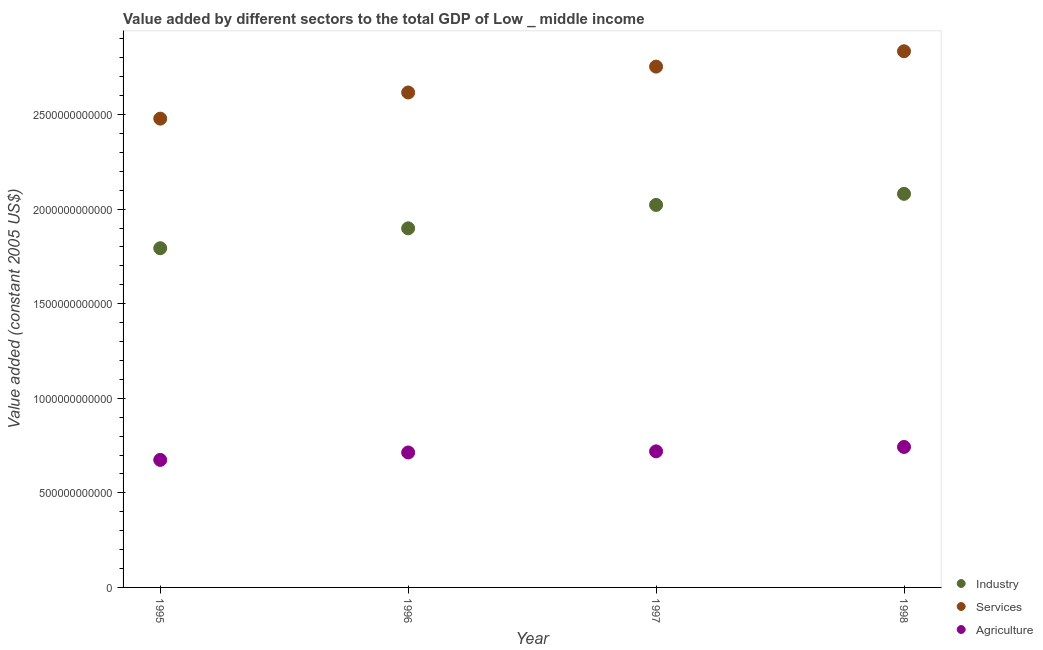What is the value added by industrial sector in 1997?
Ensure brevity in your answer.  2.02e+12. Across all years, what is the maximum value added by industrial sector?
Make the answer very short. 2.08e+12. Across all years, what is the minimum value added by agricultural sector?
Ensure brevity in your answer.  6.74e+11. In which year was the value added by services minimum?
Provide a succinct answer. 1995. What is the total value added by services in the graph?
Provide a succinct answer. 1.07e+13. What is the difference between the value added by services in 1996 and that in 1997?
Offer a very short reply. -1.37e+11. What is the difference between the value added by services in 1998 and the value added by industrial sector in 1995?
Your response must be concise. 1.04e+12. What is the average value added by agricultural sector per year?
Offer a very short reply. 7.12e+11. In the year 1995, what is the difference between the value added by agricultural sector and value added by services?
Your answer should be compact. -1.80e+12. What is the ratio of the value added by industrial sector in 1995 to that in 1997?
Make the answer very short. 0.89. Is the value added by services in 1995 less than that in 1996?
Make the answer very short. Yes. Is the difference between the value added by agricultural sector in 1995 and 1998 greater than the difference between the value added by services in 1995 and 1998?
Your answer should be very brief. Yes. What is the difference between the highest and the second highest value added by industrial sector?
Offer a very short reply. 5.85e+1. What is the difference between the highest and the lowest value added by industrial sector?
Give a very brief answer. 2.88e+11. In how many years, is the value added by agricultural sector greater than the average value added by agricultural sector taken over all years?
Your answer should be compact. 3. Is the value added by industrial sector strictly greater than the value added by services over the years?
Ensure brevity in your answer.  No. How many dotlines are there?
Offer a very short reply. 3. How many years are there in the graph?
Give a very brief answer. 4. What is the difference between two consecutive major ticks on the Y-axis?
Keep it short and to the point. 5.00e+11. Are the values on the major ticks of Y-axis written in scientific E-notation?
Offer a very short reply. No. Does the graph contain grids?
Keep it short and to the point. No. How many legend labels are there?
Your answer should be very brief. 3. How are the legend labels stacked?
Offer a very short reply. Vertical. What is the title of the graph?
Your response must be concise. Value added by different sectors to the total GDP of Low _ middle income. What is the label or title of the Y-axis?
Your response must be concise. Value added (constant 2005 US$). What is the Value added (constant 2005 US$) in Industry in 1995?
Your response must be concise. 1.79e+12. What is the Value added (constant 2005 US$) in Services in 1995?
Ensure brevity in your answer.  2.48e+12. What is the Value added (constant 2005 US$) of Agriculture in 1995?
Ensure brevity in your answer.  6.74e+11. What is the Value added (constant 2005 US$) in Industry in 1996?
Your answer should be compact. 1.90e+12. What is the Value added (constant 2005 US$) of Services in 1996?
Make the answer very short. 2.62e+12. What is the Value added (constant 2005 US$) in Agriculture in 1996?
Provide a short and direct response. 7.13e+11. What is the Value added (constant 2005 US$) in Industry in 1997?
Your answer should be compact. 2.02e+12. What is the Value added (constant 2005 US$) in Services in 1997?
Your answer should be compact. 2.75e+12. What is the Value added (constant 2005 US$) in Agriculture in 1997?
Provide a short and direct response. 7.19e+11. What is the Value added (constant 2005 US$) in Industry in 1998?
Make the answer very short. 2.08e+12. What is the Value added (constant 2005 US$) in Services in 1998?
Ensure brevity in your answer.  2.83e+12. What is the Value added (constant 2005 US$) in Agriculture in 1998?
Your response must be concise. 7.43e+11. Across all years, what is the maximum Value added (constant 2005 US$) of Industry?
Offer a very short reply. 2.08e+12. Across all years, what is the maximum Value added (constant 2005 US$) of Services?
Offer a very short reply. 2.83e+12. Across all years, what is the maximum Value added (constant 2005 US$) of Agriculture?
Provide a short and direct response. 7.43e+11. Across all years, what is the minimum Value added (constant 2005 US$) in Industry?
Provide a succinct answer. 1.79e+12. Across all years, what is the minimum Value added (constant 2005 US$) of Services?
Provide a short and direct response. 2.48e+12. Across all years, what is the minimum Value added (constant 2005 US$) of Agriculture?
Offer a terse response. 6.74e+11. What is the total Value added (constant 2005 US$) of Industry in the graph?
Give a very brief answer. 7.80e+12. What is the total Value added (constant 2005 US$) in Services in the graph?
Offer a terse response. 1.07e+13. What is the total Value added (constant 2005 US$) of Agriculture in the graph?
Ensure brevity in your answer.  2.85e+12. What is the difference between the Value added (constant 2005 US$) in Industry in 1995 and that in 1996?
Offer a terse response. -1.05e+11. What is the difference between the Value added (constant 2005 US$) of Services in 1995 and that in 1996?
Give a very brief answer. -1.38e+11. What is the difference between the Value added (constant 2005 US$) of Agriculture in 1995 and that in 1996?
Offer a very short reply. -3.93e+1. What is the difference between the Value added (constant 2005 US$) in Industry in 1995 and that in 1997?
Provide a succinct answer. -2.29e+11. What is the difference between the Value added (constant 2005 US$) in Services in 1995 and that in 1997?
Your answer should be compact. -2.75e+11. What is the difference between the Value added (constant 2005 US$) of Agriculture in 1995 and that in 1997?
Keep it short and to the point. -4.52e+1. What is the difference between the Value added (constant 2005 US$) of Industry in 1995 and that in 1998?
Give a very brief answer. -2.88e+11. What is the difference between the Value added (constant 2005 US$) in Services in 1995 and that in 1998?
Keep it short and to the point. -3.56e+11. What is the difference between the Value added (constant 2005 US$) in Agriculture in 1995 and that in 1998?
Keep it short and to the point. -6.84e+1. What is the difference between the Value added (constant 2005 US$) of Industry in 1996 and that in 1997?
Offer a terse response. -1.24e+11. What is the difference between the Value added (constant 2005 US$) in Services in 1996 and that in 1997?
Your answer should be very brief. -1.37e+11. What is the difference between the Value added (constant 2005 US$) of Agriculture in 1996 and that in 1997?
Your answer should be very brief. -5.94e+09. What is the difference between the Value added (constant 2005 US$) of Industry in 1996 and that in 1998?
Provide a short and direct response. -1.82e+11. What is the difference between the Value added (constant 2005 US$) of Services in 1996 and that in 1998?
Your response must be concise. -2.18e+11. What is the difference between the Value added (constant 2005 US$) in Agriculture in 1996 and that in 1998?
Give a very brief answer. -2.91e+1. What is the difference between the Value added (constant 2005 US$) in Industry in 1997 and that in 1998?
Ensure brevity in your answer.  -5.85e+1. What is the difference between the Value added (constant 2005 US$) of Services in 1997 and that in 1998?
Provide a short and direct response. -8.12e+1. What is the difference between the Value added (constant 2005 US$) of Agriculture in 1997 and that in 1998?
Give a very brief answer. -2.32e+1. What is the difference between the Value added (constant 2005 US$) of Industry in 1995 and the Value added (constant 2005 US$) of Services in 1996?
Give a very brief answer. -8.23e+11. What is the difference between the Value added (constant 2005 US$) of Industry in 1995 and the Value added (constant 2005 US$) of Agriculture in 1996?
Offer a very short reply. 1.08e+12. What is the difference between the Value added (constant 2005 US$) of Services in 1995 and the Value added (constant 2005 US$) of Agriculture in 1996?
Offer a terse response. 1.77e+12. What is the difference between the Value added (constant 2005 US$) in Industry in 1995 and the Value added (constant 2005 US$) in Services in 1997?
Your answer should be very brief. -9.60e+11. What is the difference between the Value added (constant 2005 US$) of Industry in 1995 and the Value added (constant 2005 US$) of Agriculture in 1997?
Keep it short and to the point. 1.07e+12. What is the difference between the Value added (constant 2005 US$) in Services in 1995 and the Value added (constant 2005 US$) in Agriculture in 1997?
Your response must be concise. 1.76e+12. What is the difference between the Value added (constant 2005 US$) of Industry in 1995 and the Value added (constant 2005 US$) of Services in 1998?
Your response must be concise. -1.04e+12. What is the difference between the Value added (constant 2005 US$) of Industry in 1995 and the Value added (constant 2005 US$) of Agriculture in 1998?
Provide a short and direct response. 1.05e+12. What is the difference between the Value added (constant 2005 US$) in Services in 1995 and the Value added (constant 2005 US$) in Agriculture in 1998?
Make the answer very short. 1.74e+12. What is the difference between the Value added (constant 2005 US$) of Industry in 1996 and the Value added (constant 2005 US$) of Services in 1997?
Keep it short and to the point. -8.55e+11. What is the difference between the Value added (constant 2005 US$) in Industry in 1996 and the Value added (constant 2005 US$) in Agriculture in 1997?
Your answer should be compact. 1.18e+12. What is the difference between the Value added (constant 2005 US$) in Services in 1996 and the Value added (constant 2005 US$) in Agriculture in 1997?
Your response must be concise. 1.90e+12. What is the difference between the Value added (constant 2005 US$) of Industry in 1996 and the Value added (constant 2005 US$) of Services in 1998?
Give a very brief answer. -9.36e+11. What is the difference between the Value added (constant 2005 US$) of Industry in 1996 and the Value added (constant 2005 US$) of Agriculture in 1998?
Keep it short and to the point. 1.16e+12. What is the difference between the Value added (constant 2005 US$) in Services in 1996 and the Value added (constant 2005 US$) in Agriculture in 1998?
Provide a short and direct response. 1.87e+12. What is the difference between the Value added (constant 2005 US$) of Industry in 1997 and the Value added (constant 2005 US$) of Services in 1998?
Your answer should be compact. -8.12e+11. What is the difference between the Value added (constant 2005 US$) of Industry in 1997 and the Value added (constant 2005 US$) of Agriculture in 1998?
Offer a terse response. 1.28e+12. What is the difference between the Value added (constant 2005 US$) of Services in 1997 and the Value added (constant 2005 US$) of Agriculture in 1998?
Offer a very short reply. 2.01e+12. What is the average Value added (constant 2005 US$) in Industry per year?
Provide a short and direct response. 1.95e+12. What is the average Value added (constant 2005 US$) in Services per year?
Provide a succinct answer. 2.67e+12. What is the average Value added (constant 2005 US$) of Agriculture per year?
Provide a short and direct response. 7.12e+11. In the year 1995, what is the difference between the Value added (constant 2005 US$) of Industry and Value added (constant 2005 US$) of Services?
Your response must be concise. -6.85e+11. In the year 1995, what is the difference between the Value added (constant 2005 US$) in Industry and Value added (constant 2005 US$) in Agriculture?
Keep it short and to the point. 1.12e+12. In the year 1995, what is the difference between the Value added (constant 2005 US$) of Services and Value added (constant 2005 US$) of Agriculture?
Provide a succinct answer. 1.80e+12. In the year 1996, what is the difference between the Value added (constant 2005 US$) of Industry and Value added (constant 2005 US$) of Services?
Provide a succinct answer. -7.18e+11. In the year 1996, what is the difference between the Value added (constant 2005 US$) in Industry and Value added (constant 2005 US$) in Agriculture?
Provide a short and direct response. 1.19e+12. In the year 1996, what is the difference between the Value added (constant 2005 US$) in Services and Value added (constant 2005 US$) in Agriculture?
Your response must be concise. 1.90e+12. In the year 1997, what is the difference between the Value added (constant 2005 US$) in Industry and Value added (constant 2005 US$) in Services?
Keep it short and to the point. -7.31e+11. In the year 1997, what is the difference between the Value added (constant 2005 US$) of Industry and Value added (constant 2005 US$) of Agriculture?
Provide a succinct answer. 1.30e+12. In the year 1997, what is the difference between the Value added (constant 2005 US$) of Services and Value added (constant 2005 US$) of Agriculture?
Give a very brief answer. 2.03e+12. In the year 1998, what is the difference between the Value added (constant 2005 US$) of Industry and Value added (constant 2005 US$) of Services?
Give a very brief answer. -7.54e+11. In the year 1998, what is the difference between the Value added (constant 2005 US$) in Industry and Value added (constant 2005 US$) in Agriculture?
Make the answer very short. 1.34e+12. In the year 1998, what is the difference between the Value added (constant 2005 US$) of Services and Value added (constant 2005 US$) of Agriculture?
Your answer should be compact. 2.09e+12. What is the ratio of the Value added (constant 2005 US$) of Industry in 1995 to that in 1996?
Keep it short and to the point. 0.94. What is the ratio of the Value added (constant 2005 US$) of Services in 1995 to that in 1996?
Your answer should be compact. 0.95. What is the ratio of the Value added (constant 2005 US$) in Agriculture in 1995 to that in 1996?
Offer a terse response. 0.94. What is the ratio of the Value added (constant 2005 US$) in Industry in 1995 to that in 1997?
Offer a terse response. 0.89. What is the ratio of the Value added (constant 2005 US$) of Services in 1995 to that in 1997?
Provide a short and direct response. 0.9. What is the ratio of the Value added (constant 2005 US$) in Agriculture in 1995 to that in 1997?
Make the answer very short. 0.94. What is the ratio of the Value added (constant 2005 US$) of Industry in 1995 to that in 1998?
Your response must be concise. 0.86. What is the ratio of the Value added (constant 2005 US$) of Services in 1995 to that in 1998?
Your answer should be very brief. 0.87. What is the ratio of the Value added (constant 2005 US$) of Agriculture in 1995 to that in 1998?
Make the answer very short. 0.91. What is the ratio of the Value added (constant 2005 US$) in Industry in 1996 to that in 1997?
Make the answer very short. 0.94. What is the ratio of the Value added (constant 2005 US$) in Services in 1996 to that in 1997?
Your answer should be compact. 0.95. What is the ratio of the Value added (constant 2005 US$) of Agriculture in 1996 to that in 1997?
Your answer should be compact. 0.99. What is the ratio of the Value added (constant 2005 US$) of Industry in 1996 to that in 1998?
Give a very brief answer. 0.91. What is the ratio of the Value added (constant 2005 US$) of Agriculture in 1996 to that in 1998?
Ensure brevity in your answer.  0.96. What is the ratio of the Value added (constant 2005 US$) of Industry in 1997 to that in 1998?
Make the answer very short. 0.97. What is the ratio of the Value added (constant 2005 US$) in Services in 1997 to that in 1998?
Provide a short and direct response. 0.97. What is the ratio of the Value added (constant 2005 US$) of Agriculture in 1997 to that in 1998?
Ensure brevity in your answer.  0.97. What is the difference between the highest and the second highest Value added (constant 2005 US$) in Industry?
Your answer should be compact. 5.85e+1. What is the difference between the highest and the second highest Value added (constant 2005 US$) in Services?
Your answer should be very brief. 8.12e+1. What is the difference between the highest and the second highest Value added (constant 2005 US$) in Agriculture?
Provide a succinct answer. 2.32e+1. What is the difference between the highest and the lowest Value added (constant 2005 US$) in Industry?
Your answer should be compact. 2.88e+11. What is the difference between the highest and the lowest Value added (constant 2005 US$) in Services?
Make the answer very short. 3.56e+11. What is the difference between the highest and the lowest Value added (constant 2005 US$) of Agriculture?
Keep it short and to the point. 6.84e+1. 